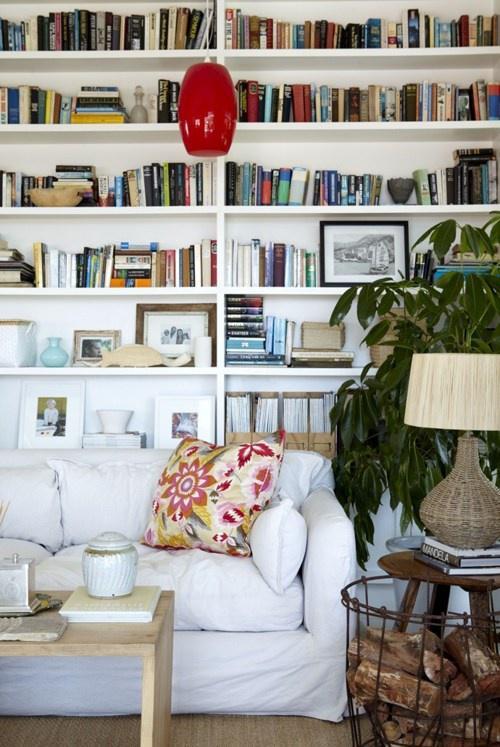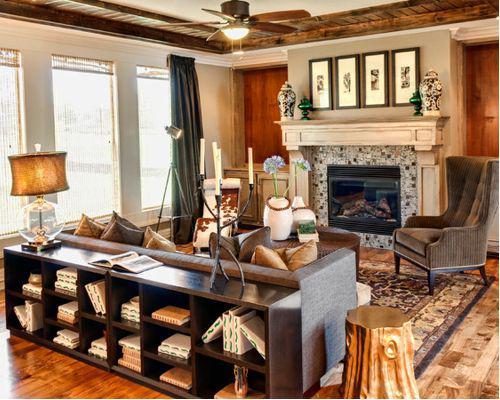The first image is the image on the left, the second image is the image on the right. Examine the images to the left and right. Is the description "In one image a couch sits across the end of a room with white shelves on the wall behind and the wall to the side." accurate? Answer yes or no. No. The first image is the image on the left, the second image is the image on the right. For the images displayed, is the sentence "A room includes a round table in front of a neutral couch, which sits in front of a wall-filling white bookcase and something olive-green." factually correct? Answer yes or no. No. 